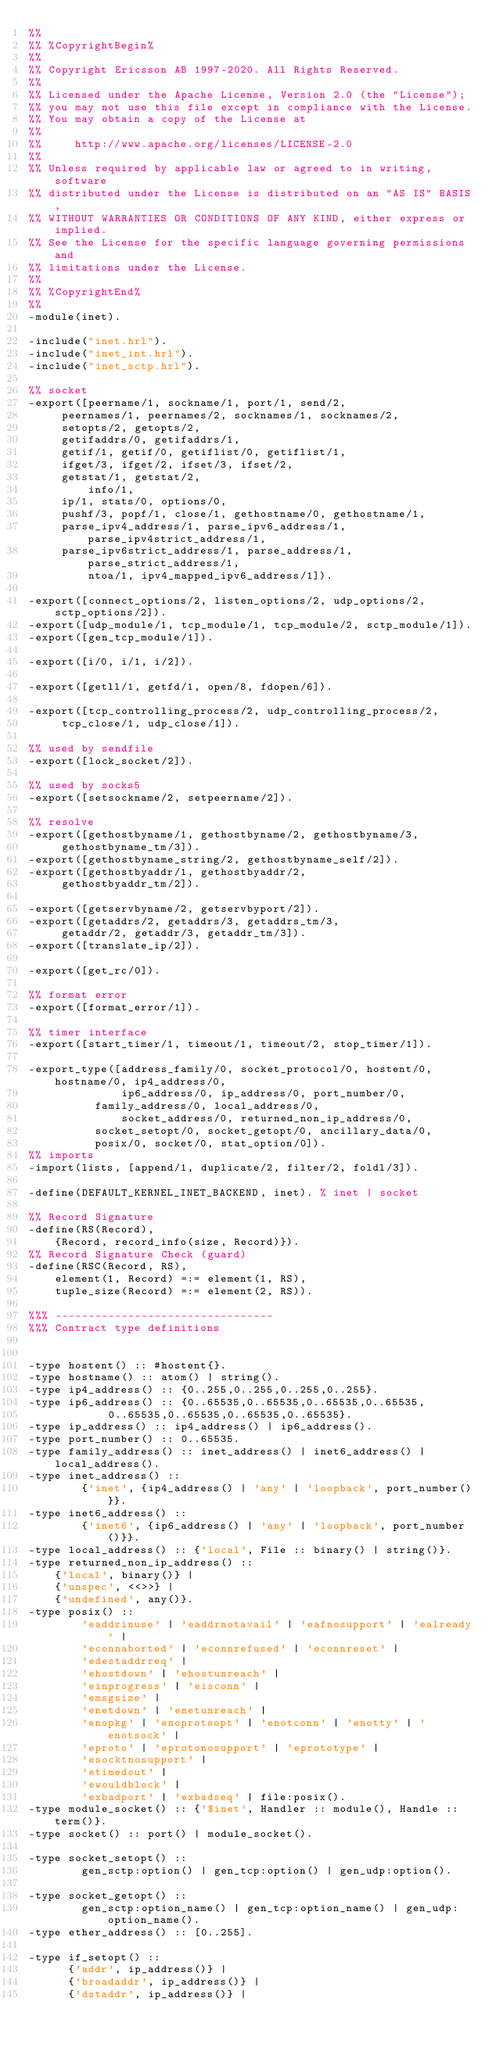<code> <loc_0><loc_0><loc_500><loc_500><_Erlang_>%%
%% %CopyrightBegin%
%%
%% Copyright Ericsson AB 1997-2020. All Rights Reserved.
%%
%% Licensed under the Apache License, Version 2.0 (the "License");
%% you may not use this file except in compliance with the License.
%% You may obtain a copy of the License at
%%
%%     http://www.apache.org/licenses/LICENSE-2.0
%%
%% Unless required by applicable law or agreed to in writing, software
%% distributed under the License is distributed on an "AS IS" BASIS,
%% WITHOUT WARRANTIES OR CONDITIONS OF ANY KIND, either express or implied.
%% See the License for the specific language governing permissions and
%% limitations under the License.
%%
%% %CopyrightEnd%
%%
-module(inet).

-include("inet.hrl").
-include("inet_int.hrl").
-include("inet_sctp.hrl").

%% socket
-export([peername/1, sockname/1, port/1, send/2,
	 peernames/1, peernames/2, socknames/1, socknames/2,
	 setopts/2, getopts/2, 
	 getifaddrs/0, getifaddrs/1,
	 getif/1, getif/0, getiflist/0, getiflist/1,
	 ifget/3, ifget/2, ifset/3, ifset/2,
	 getstat/1, getstat/2,
         info/1,
	 ip/1, stats/0, options/0, 
	 pushf/3, popf/1, close/1, gethostname/0, gethostname/1, 
	 parse_ipv4_address/1, parse_ipv6_address/1, parse_ipv4strict_address/1,
	 parse_ipv6strict_address/1, parse_address/1, parse_strict_address/1,
         ntoa/1, ipv4_mapped_ipv6_address/1]).

-export([connect_options/2, listen_options/2, udp_options/2, sctp_options/2]).
-export([udp_module/1, tcp_module/1, tcp_module/2, sctp_module/1]).
-export([gen_tcp_module/1]).

-export([i/0, i/1, i/2]).

-export([getll/1, getfd/1, open/8, fdopen/6]).

-export([tcp_controlling_process/2, udp_controlling_process/2,
	 tcp_close/1, udp_close/1]).

%% used by sendfile
-export([lock_socket/2]).

%% used by socks5
-export([setsockname/2, setpeername/2]).

%% resolve
-export([gethostbyname/1, gethostbyname/2, gethostbyname/3, 
	 gethostbyname_tm/3]).
-export([gethostbyname_string/2, gethostbyname_self/2]).
-export([gethostbyaddr/1, gethostbyaddr/2, 
	 gethostbyaddr_tm/2]).

-export([getservbyname/2, getservbyport/2]).
-export([getaddrs/2, getaddrs/3, getaddrs_tm/3,
	 getaddr/2, getaddr/3, getaddr_tm/3]).
-export([translate_ip/2]).

-export([get_rc/0]).

%% format error
-export([format_error/1]).

%% timer interface
-export([start_timer/1, timeout/1, timeout/2, stop_timer/1]).

-export_type([address_family/0, socket_protocol/0, hostent/0, hostname/0, ip4_address/0,
              ip6_address/0, ip_address/0, port_number/0,
	      family_address/0, local_address/0,
              socket_address/0, returned_non_ip_address/0,
	      socket_setopt/0, socket_getopt/0, ancillary_data/0,
	      posix/0, socket/0, stat_option/0]).
%% imports
-import(lists, [append/1, duplicate/2, filter/2, foldl/3]).

-define(DEFAULT_KERNEL_INET_BACKEND, inet). % inet | socket

%% Record Signature
-define(RS(Record),
	{Record, record_info(size, Record)}).
%% Record Signature Check (guard)
-define(RSC(Record, RS),
	element(1, Record) =:= element(1, RS),
	tuple_size(Record) =:= element(2, RS)).

%%% ---------------------------------
%%% Contract type definitions


-type hostent() :: #hostent{}.
-type hostname() :: atom() | string().
-type ip4_address() :: {0..255,0..255,0..255,0..255}.
-type ip6_address() :: {0..65535,0..65535,0..65535,0..65535,
			0..65535,0..65535,0..65535,0..65535}.
-type ip_address() :: ip4_address() | ip6_address().
-type port_number() :: 0..65535.
-type family_address() :: inet_address() | inet6_address() | local_address().
-type inet_address() ::
        {'inet', {ip4_address() | 'any' | 'loopback', port_number()}}.
-type inet6_address() ::
        {'inet6', {ip6_address() | 'any' | 'loopback', port_number()}}.
-type local_address() :: {'local', File :: binary() | string()}.
-type returned_non_ip_address() ::
	{'local', binary()} |
	{'unspec', <<>>} |
	{'undefined', any()}.
-type posix() ::
        'eaddrinuse' | 'eaddrnotavail' | 'eafnosupport' | 'ealready' |
        'econnaborted' | 'econnrefused' | 'econnreset' |
        'edestaddrreq' |
        'ehostdown' | 'ehostunreach' |
        'einprogress' | 'eisconn' |
        'emsgsize' |
        'enetdown' | 'enetunreach' |
        'enopkg' | 'enoprotoopt' | 'enotconn' | 'enotty' | 'enotsock' |
        'eproto' | 'eprotonosupport' | 'eprototype' |
        'esocktnosupport' |
        'etimedout' |
        'ewouldblock' |
        'exbadport' | 'exbadseq' | file:posix().
-type module_socket() :: {'$inet', Handler :: module(), Handle :: term()}.
-type socket() :: port() | module_socket().

-type socket_setopt() ::
        gen_sctp:option() | gen_tcp:option() | gen_udp:option().

-type socket_getopt() ::
        gen_sctp:option_name() | gen_tcp:option_name() | gen_udp:option_name().
-type ether_address() :: [0..255].

-type if_setopt() ::
      {'addr', ip_address()} |
      {'broadaddr', ip_address()} |
      {'dstaddr', ip_address()} |</code> 